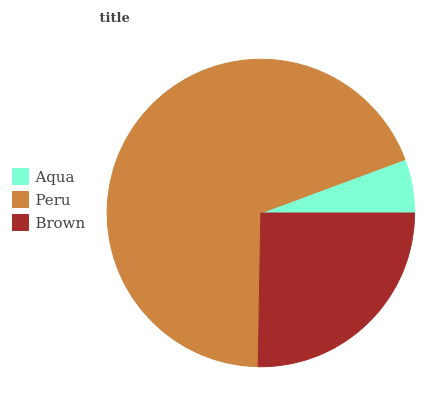Is Aqua the minimum?
Answer yes or no. Yes. Is Peru the maximum?
Answer yes or no. Yes. Is Brown the minimum?
Answer yes or no. No. Is Brown the maximum?
Answer yes or no. No. Is Peru greater than Brown?
Answer yes or no. Yes. Is Brown less than Peru?
Answer yes or no. Yes. Is Brown greater than Peru?
Answer yes or no. No. Is Peru less than Brown?
Answer yes or no. No. Is Brown the high median?
Answer yes or no. Yes. Is Brown the low median?
Answer yes or no. Yes. Is Peru the high median?
Answer yes or no. No. Is Peru the low median?
Answer yes or no. No. 